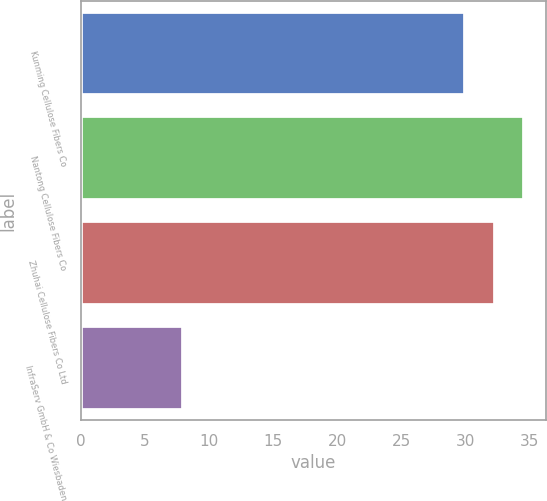<chart> <loc_0><loc_0><loc_500><loc_500><bar_chart><fcel>Kunming Cellulose Fibers Co<fcel>Nantong Cellulose Fibers Co<fcel>Zhuhai Cellulose Fibers Co Ltd<fcel>InfraServ GmbH & Co Wiesbaden<nl><fcel>30<fcel>34.6<fcel>32.3<fcel>8<nl></chart> 